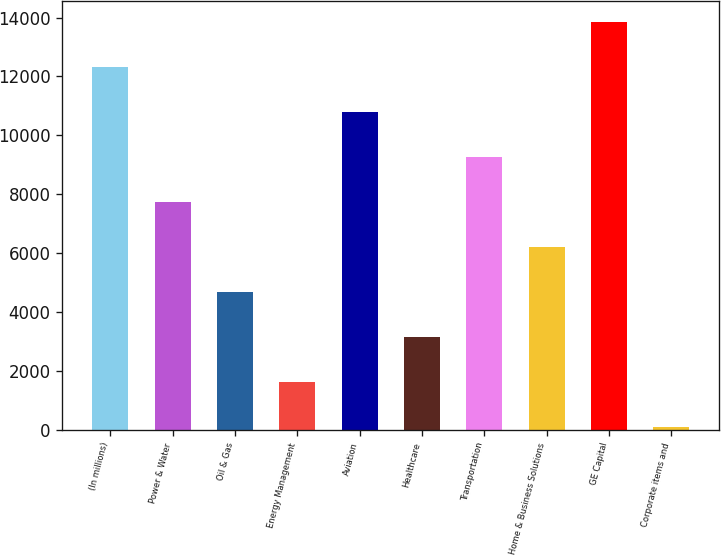<chart> <loc_0><loc_0><loc_500><loc_500><bar_chart><fcel>(In millions)<fcel>Power & Water<fcel>Oil & Gas<fcel>Energy Management<fcel>Aviation<fcel>Healthcare<fcel>Transportation<fcel>Home & Business Solutions<fcel>GE Capital<fcel>Corporate items and<nl><fcel>12325.4<fcel>7740.5<fcel>4683.9<fcel>1627.3<fcel>10797.1<fcel>3155.6<fcel>9268.8<fcel>6212.2<fcel>13853.7<fcel>99<nl></chart> 